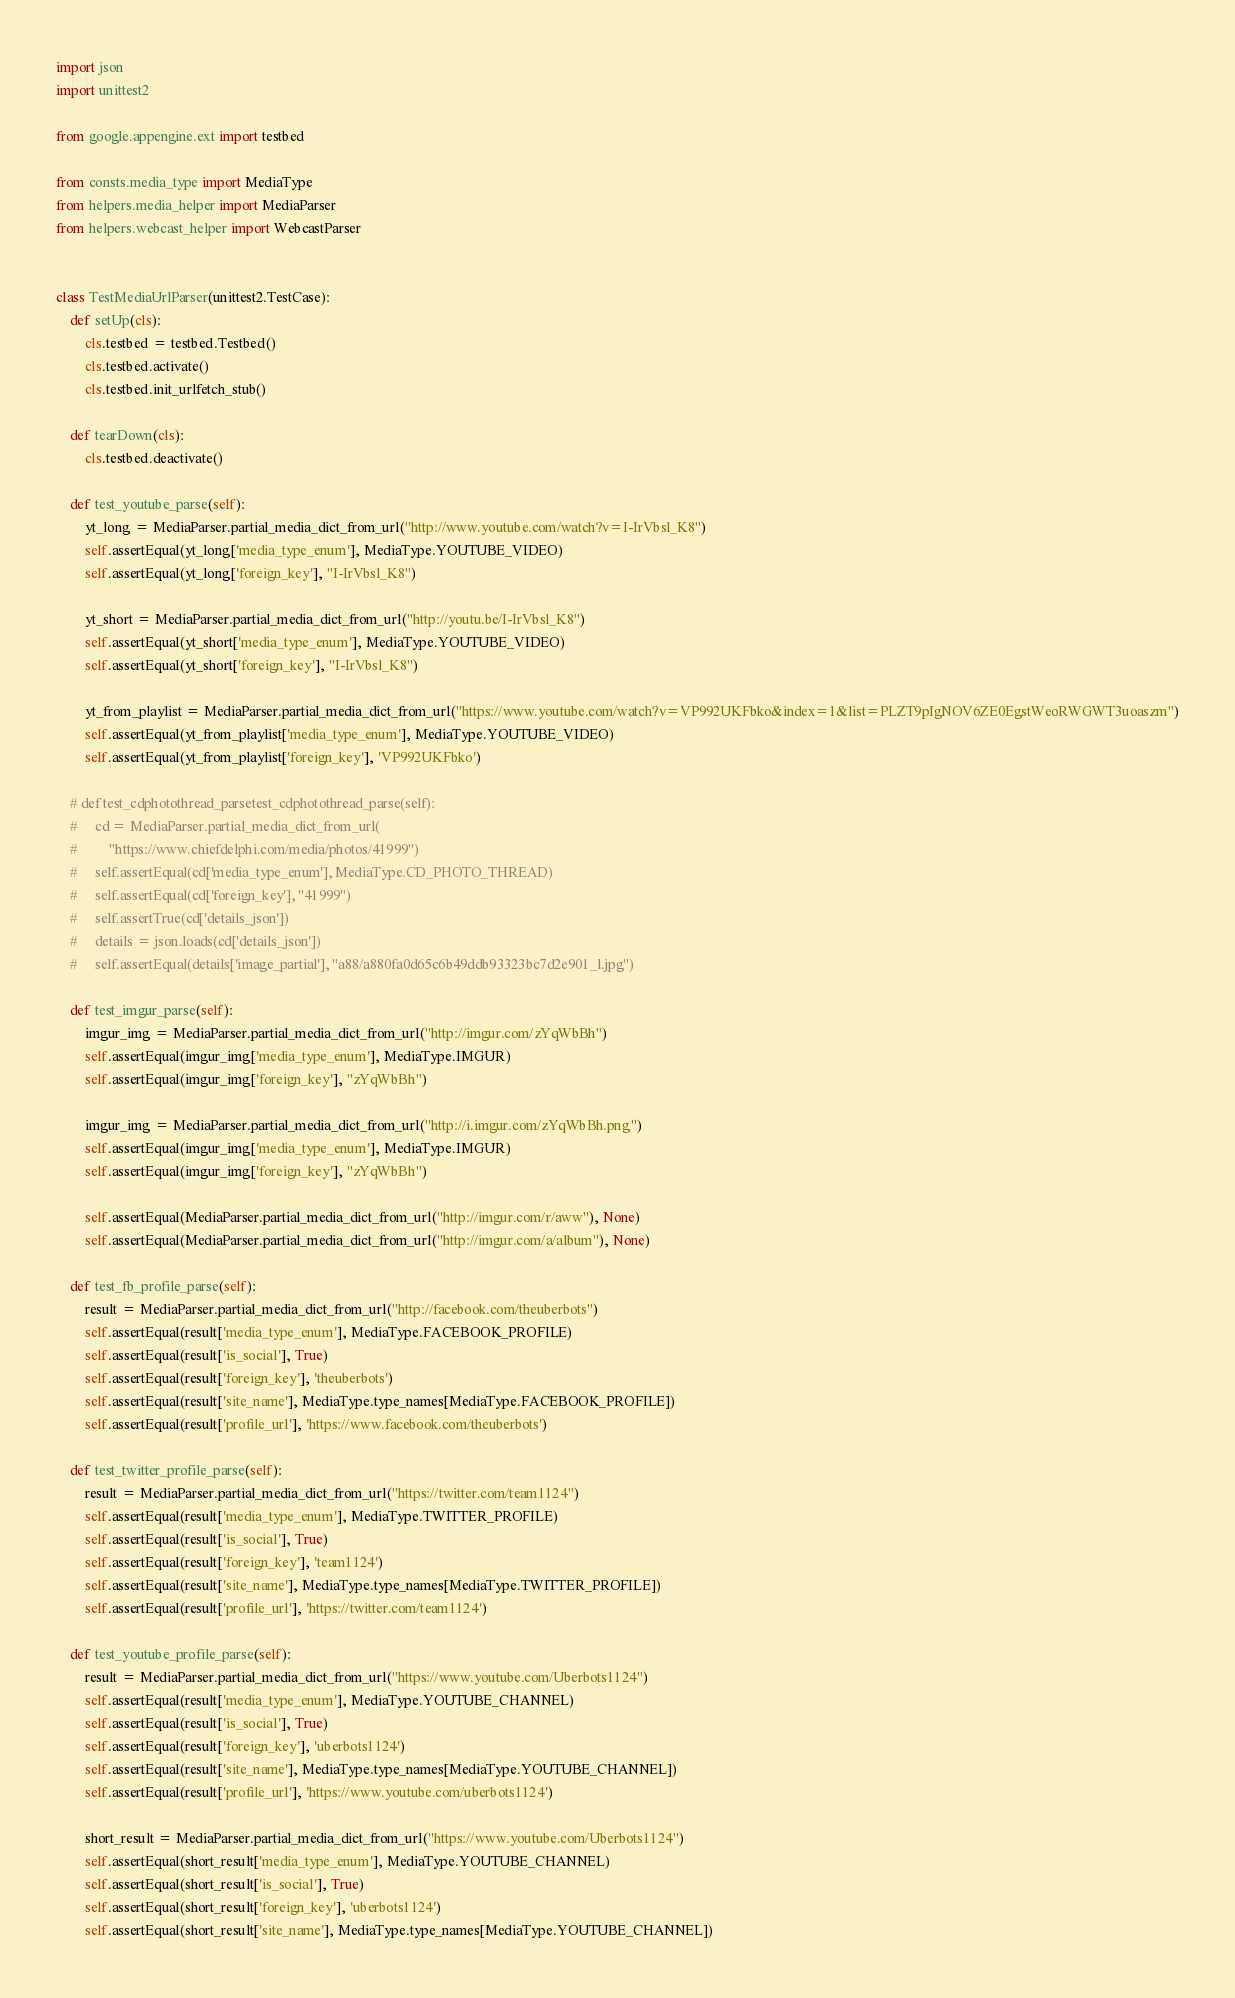Convert code to text. <code><loc_0><loc_0><loc_500><loc_500><_Python_>import json
import unittest2

from google.appengine.ext import testbed

from consts.media_type import MediaType
from helpers.media_helper import MediaParser
from helpers.webcast_helper import WebcastParser


class TestMediaUrlParser(unittest2.TestCase):
    def setUp(cls):
        cls.testbed = testbed.Testbed()
        cls.testbed.activate()
        cls.testbed.init_urlfetch_stub()

    def tearDown(cls):
        cls.testbed.deactivate()

    def test_youtube_parse(self):
        yt_long = MediaParser.partial_media_dict_from_url("http://www.youtube.com/watch?v=I-IrVbsl_K8")
        self.assertEqual(yt_long['media_type_enum'], MediaType.YOUTUBE_VIDEO)
        self.assertEqual(yt_long['foreign_key'], "I-IrVbsl_K8")

        yt_short = MediaParser.partial_media_dict_from_url("http://youtu.be/I-IrVbsl_K8")
        self.assertEqual(yt_short['media_type_enum'], MediaType.YOUTUBE_VIDEO)
        self.assertEqual(yt_short['foreign_key'], "I-IrVbsl_K8")

        yt_from_playlist = MediaParser.partial_media_dict_from_url("https://www.youtube.com/watch?v=VP992UKFbko&index=1&list=PLZT9pIgNOV6ZE0EgstWeoRWGWT3uoaszm")
        self.assertEqual(yt_from_playlist['media_type_enum'], MediaType.YOUTUBE_VIDEO)
        self.assertEqual(yt_from_playlist['foreign_key'], 'VP992UKFbko')

    # def test_cdphotothread_parsetest_cdphotothread_parse(self):
    #     cd = MediaParser.partial_media_dict_from_url(
    #         "https://www.chiefdelphi.com/media/photos/41999")
    #     self.assertEqual(cd['media_type_enum'], MediaType.CD_PHOTO_THREAD)
    #     self.assertEqual(cd['foreign_key'], "41999")
    #     self.assertTrue(cd['details_json'])
    #     details = json.loads(cd['details_json'])
    #     self.assertEqual(details['image_partial'], "a88/a880fa0d65c6b49ddb93323bc7d2e901_l.jpg")

    def test_imgur_parse(self):
        imgur_img = MediaParser.partial_media_dict_from_url("http://imgur.com/zYqWbBh")
        self.assertEqual(imgur_img['media_type_enum'], MediaType.IMGUR)
        self.assertEqual(imgur_img['foreign_key'], "zYqWbBh")

        imgur_img = MediaParser.partial_media_dict_from_url("http://i.imgur.com/zYqWbBh.png")
        self.assertEqual(imgur_img['media_type_enum'], MediaType.IMGUR)
        self.assertEqual(imgur_img['foreign_key'], "zYqWbBh")

        self.assertEqual(MediaParser.partial_media_dict_from_url("http://imgur.com/r/aww"), None)
        self.assertEqual(MediaParser.partial_media_dict_from_url("http://imgur.com/a/album"), None)

    def test_fb_profile_parse(self):
        result = MediaParser.partial_media_dict_from_url("http://facebook.com/theuberbots")
        self.assertEqual(result['media_type_enum'], MediaType.FACEBOOK_PROFILE)
        self.assertEqual(result['is_social'], True)
        self.assertEqual(result['foreign_key'], 'theuberbots')
        self.assertEqual(result['site_name'], MediaType.type_names[MediaType.FACEBOOK_PROFILE])
        self.assertEqual(result['profile_url'], 'https://www.facebook.com/theuberbots')

    def test_twitter_profile_parse(self):
        result = MediaParser.partial_media_dict_from_url("https://twitter.com/team1124")
        self.assertEqual(result['media_type_enum'], MediaType.TWITTER_PROFILE)
        self.assertEqual(result['is_social'], True)
        self.assertEqual(result['foreign_key'], 'team1124')
        self.assertEqual(result['site_name'], MediaType.type_names[MediaType.TWITTER_PROFILE])
        self.assertEqual(result['profile_url'], 'https://twitter.com/team1124')

    def test_youtube_profile_parse(self):
        result = MediaParser.partial_media_dict_from_url("https://www.youtube.com/Uberbots1124")
        self.assertEqual(result['media_type_enum'], MediaType.YOUTUBE_CHANNEL)
        self.assertEqual(result['is_social'], True)
        self.assertEqual(result['foreign_key'], 'uberbots1124')
        self.assertEqual(result['site_name'], MediaType.type_names[MediaType.YOUTUBE_CHANNEL])
        self.assertEqual(result['profile_url'], 'https://www.youtube.com/uberbots1124')

        short_result = MediaParser.partial_media_dict_from_url("https://www.youtube.com/Uberbots1124")
        self.assertEqual(short_result['media_type_enum'], MediaType.YOUTUBE_CHANNEL)
        self.assertEqual(short_result['is_social'], True)
        self.assertEqual(short_result['foreign_key'], 'uberbots1124')
        self.assertEqual(short_result['site_name'], MediaType.type_names[MediaType.YOUTUBE_CHANNEL])</code> 